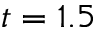<formula> <loc_0><loc_0><loc_500><loc_500>t = 1 . 5</formula> 